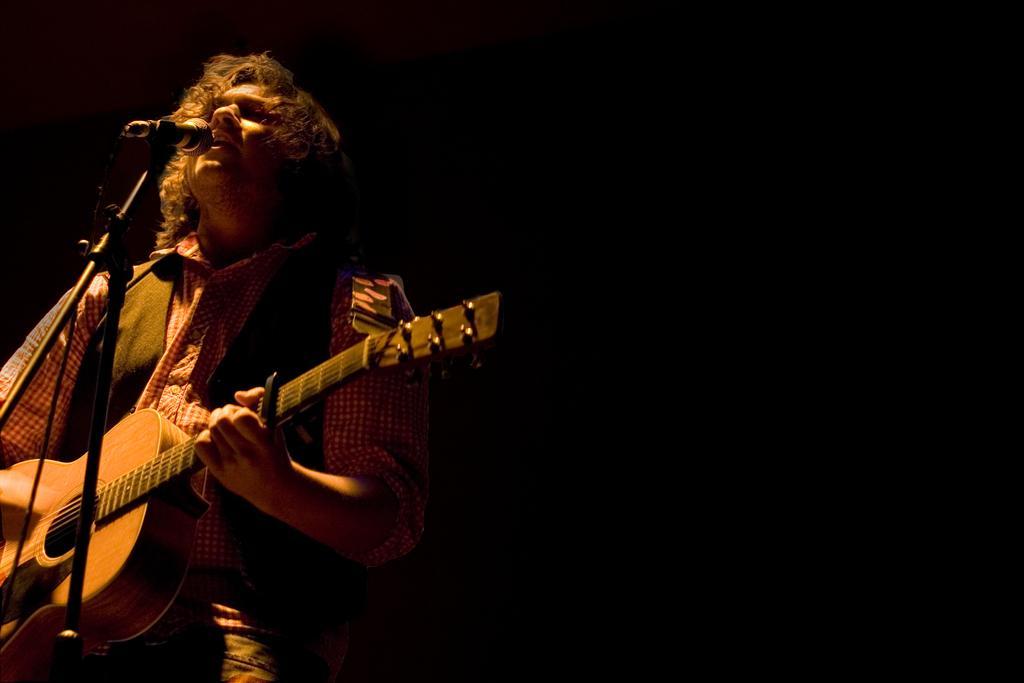Can you describe this image briefly? In this image i can see a man holding a guitar and singing in front of a micro phone. 